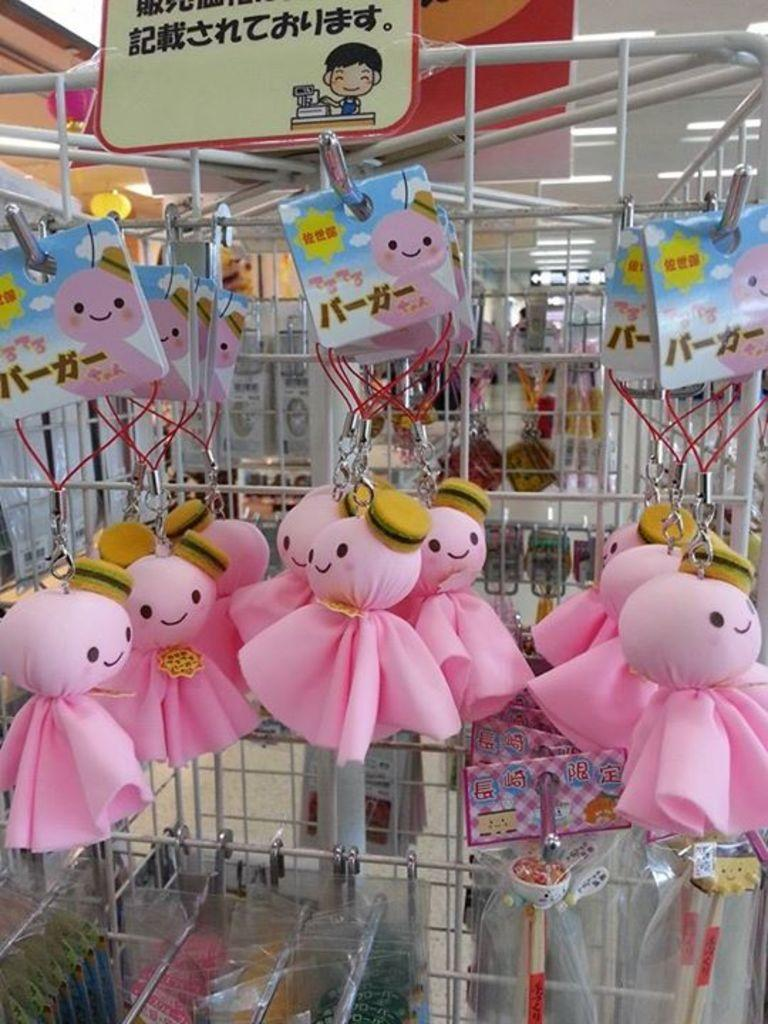What type of toys can be seen in the image? There are dolls in the image. What is the condition of the objects in plastic covers? The objects in plastic covers are hung on hooks. Where are the hooks attached in the image? The hooks are attached to a stand. What can be seen in the background of the image? There are electric lights in the background of the image. What type of store is depicted in the image? There is no store present in the image; it features dolls and objects in plastic covers hung on hooks attached to a stand. What kind of apparatus is used to hang the objects in plastic covers in the image? The objects in plastic covers are hung on hooks, but there is no specific apparatus mentioned in the image. 